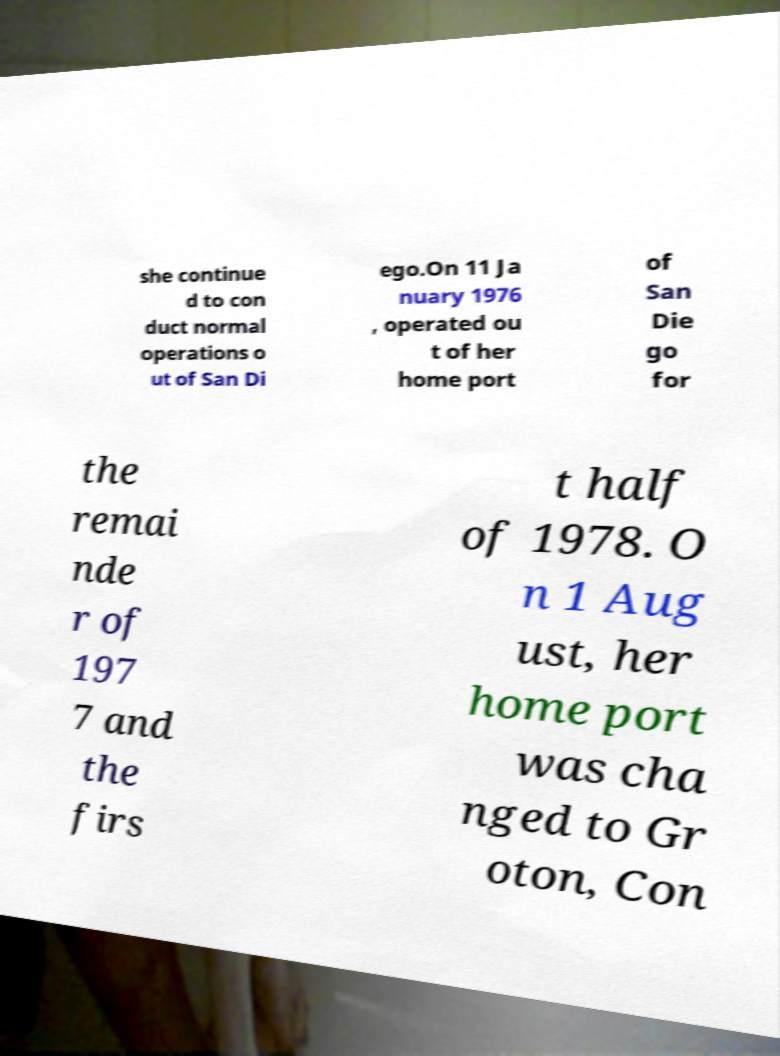For documentation purposes, I need the text within this image transcribed. Could you provide that? she continue d to con duct normal operations o ut of San Di ego.On 11 Ja nuary 1976 , operated ou t of her home port of San Die go for the remai nde r of 197 7 and the firs t half of 1978. O n 1 Aug ust, her home port was cha nged to Gr oton, Con 